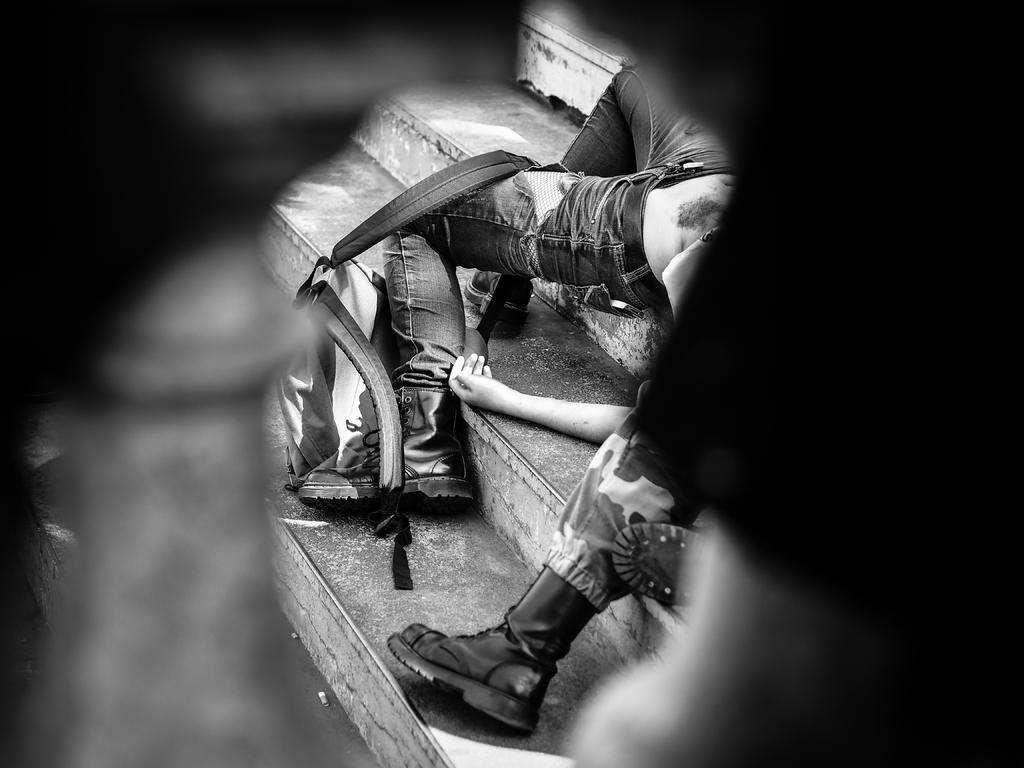What body parts of people can be seen in the image? People's legs and hands are visible in the image. What objects are present on the steps in the image? Bags are visible on the steps. What type of knot is being tied by the person in the image? There is no person tying a knot in the image; only people's legs and hands are visible. What color is the cushion on the steps in the image? There is no cushion present in the image. 